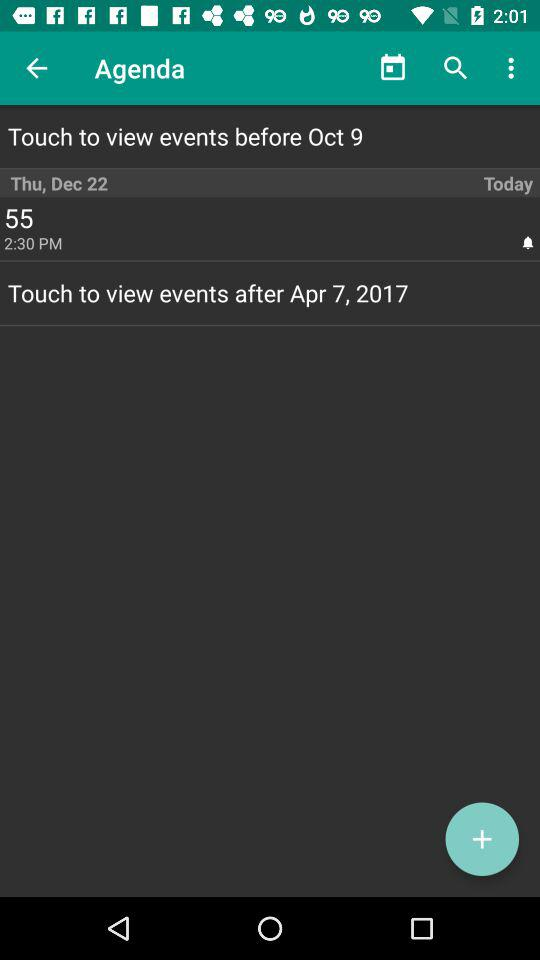At what time will event 55 start? It will start at 2:30 PM. 